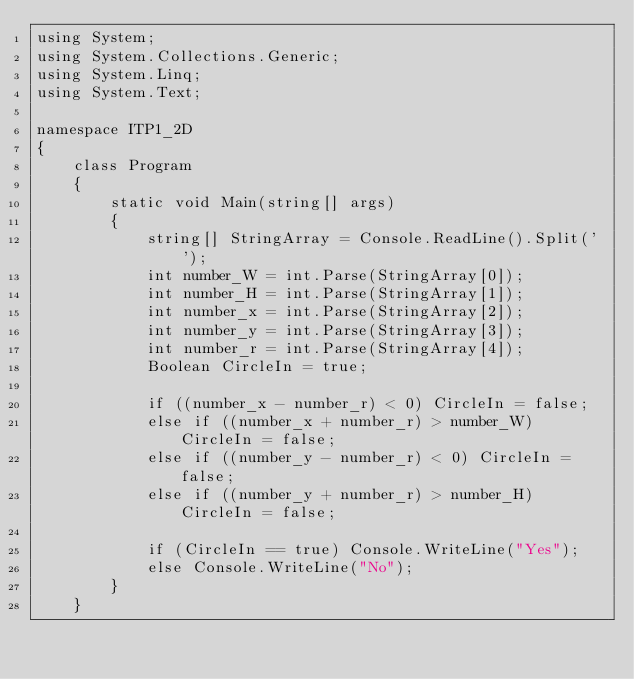Convert code to text. <code><loc_0><loc_0><loc_500><loc_500><_C#_>using System;
using System.Collections.Generic;
using System.Linq;
using System.Text;

namespace ITP1_2D
{
    class Program
    {
        static void Main(string[] args)
        {
            string[] StringArray = Console.ReadLine().Split(' ');
            int number_W = int.Parse(StringArray[0]);
            int number_H = int.Parse(StringArray[1]);
            int number_x = int.Parse(StringArray[2]);
            int number_y = int.Parse(StringArray[3]);
            int number_r = int.Parse(StringArray[4]);
            Boolean CircleIn = true;

            if ((number_x - number_r) < 0) CircleIn = false;
            else if ((number_x + number_r) > number_W) CircleIn = false;
            else if ((number_y - number_r) < 0) CircleIn = false;
            else if ((number_y + number_r) > number_H) CircleIn = false;

            if (CircleIn == true) Console.WriteLine("Yes");
            else Console.WriteLine("No");
        }
    }</code> 